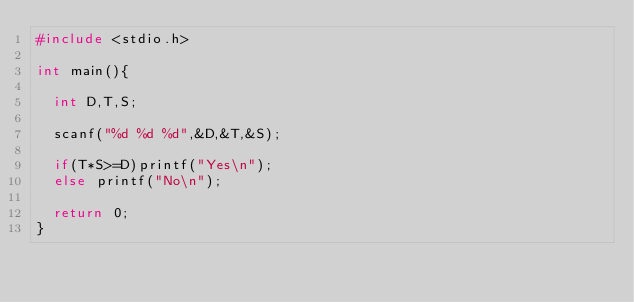Convert code to text. <code><loc_0><loc_0><loc_500><loc_500><_C_>#include <stdio.h>

int main(){
  
  int D,T,S;
  
  scanf("%d %d %d",&D,&T,&S);
  
  if(T*S>=D)printf("Yes\n");
  else printf("No\n");
  
  return 0;
}</code> 